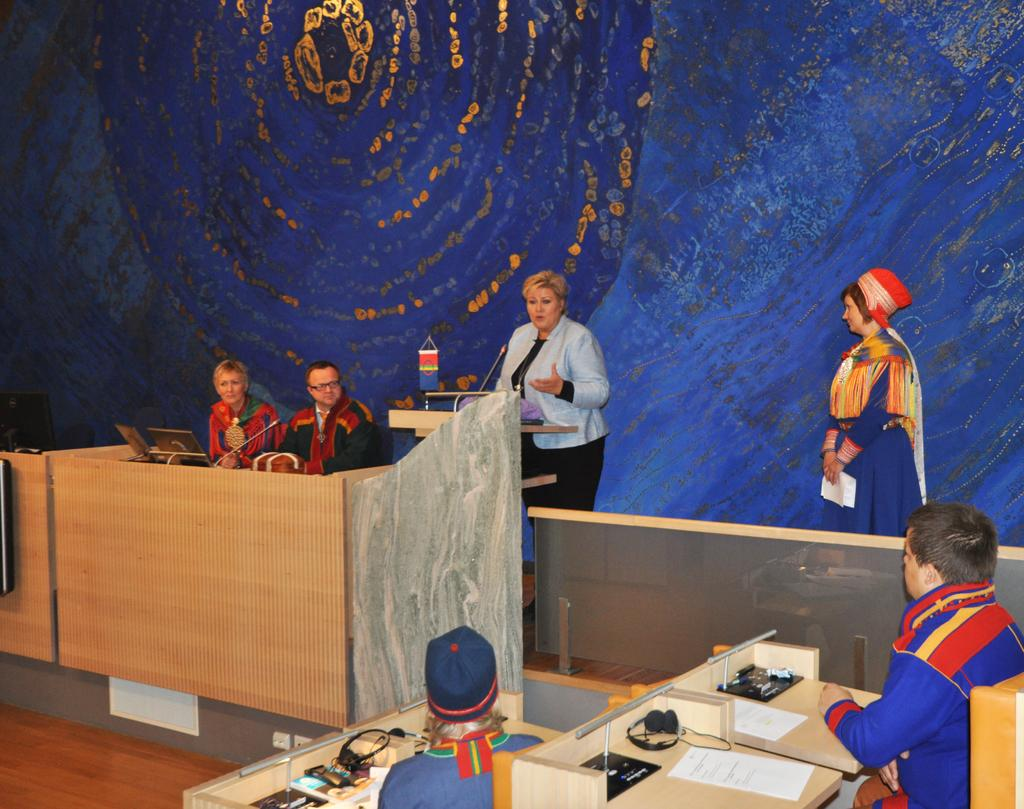How many people are in the image? There are persons in the image, but the exact number is not specified. What is one person doing in the image? One person is talking on a microphone. What type of furniture is present in the image? There are tables in the image. What items are related to communication in the image? Papers, headsets, laptops, and microphones are present in the image. What part of the room can be seen in the image? The floor is visible in the image. What is the color of the background in the image? The background has a blue color. How many legs can be seen on the family members in the image? There is no mention of a family in the image, and therefore no family members or legs can be seen. 